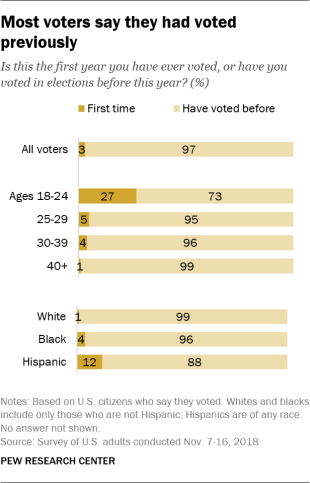Give some essential details in this illustration. The age group that has the highest voter turnout this year is 40 years old and above. The value is more than 90 times in the chart. 